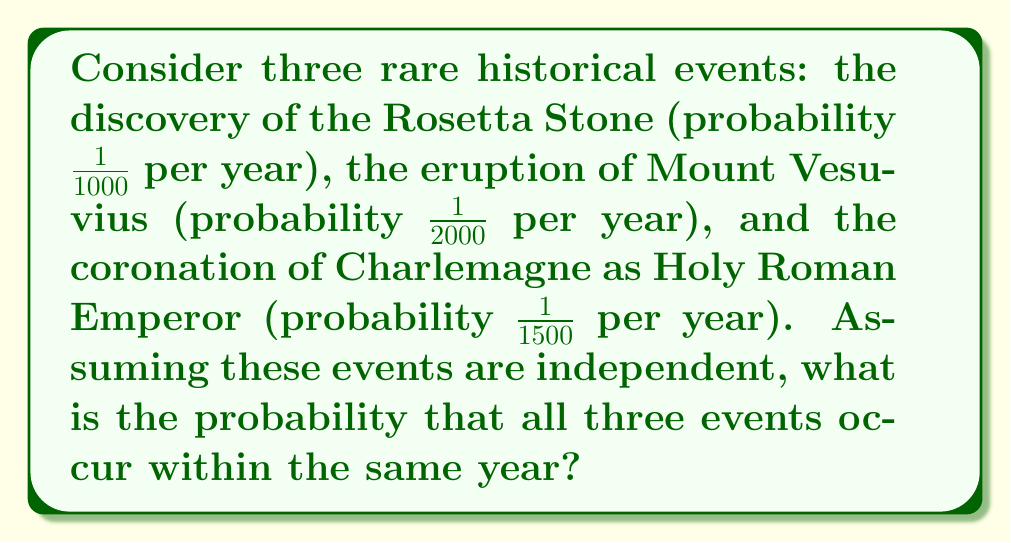Teach me how to tackle this problem. To solve this problem, we'll follow these steps:

1) First, recall that for independent events, the probability of all events occurring simultaneously is the product of their individual probabilities.

2) Let's define our events:
   A: Discovery of the Rosetta Stone
   B: Eruption of Mount Vesuvius
   C: Coronation of Charlemagne

3) Given probabilities:
   P(A) = $\frac{1}{1000}$
   P(B) = $\frac{1}{2000}$
   P(C) = $\frac{1}{1500}$

4) The probability of all three events occurring in the same year is:
   P(A ∩ B ∩ C) = P(A) × P(B) × P(C)

5) Substituting the values:
   P(A ∩ B ∩ C) = $\frac{1}{1000} \times \frac{1}{2000} \times \frac{1}{1500}$

6) Multiply the fractions:
   P(A ∩ B ∩ C) = $\frac{1}{3,000,000,000}$

7) This can be written in scientific notation as $3.33 \times 10^{-10}$
Answer: $\frac{1}{3,000,000,000}$ or $3.33 \times 10^{-10}$ 